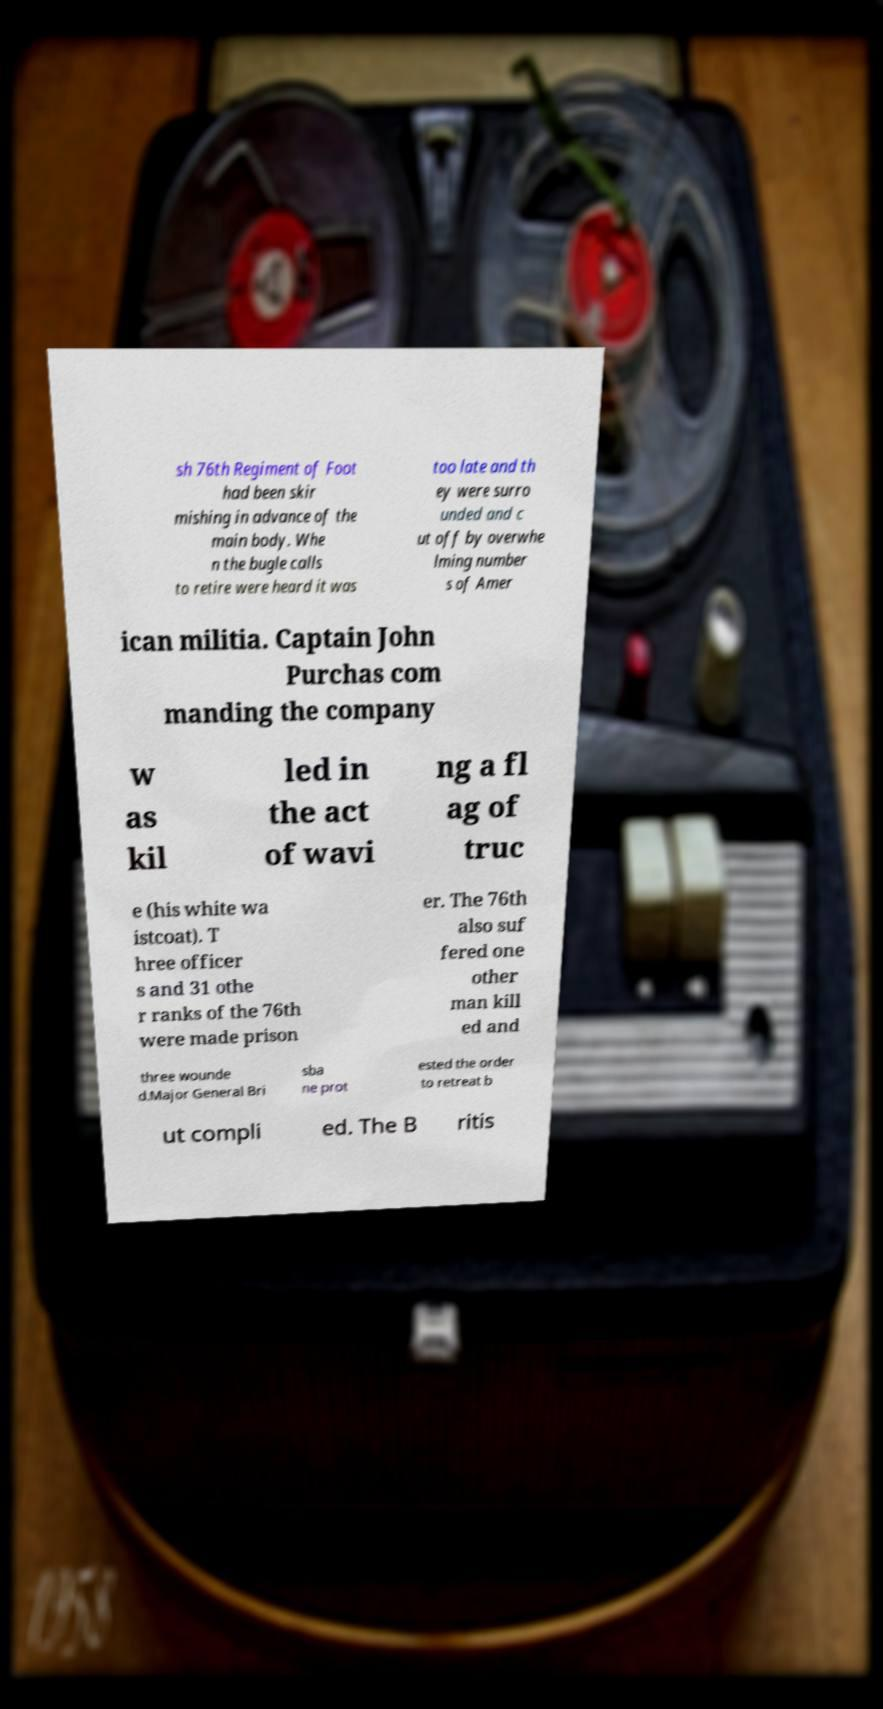Please read and relay the text visible in this image. What does it say? sh 76th Regiment of Foot had been skir mishing in advance of the main body. Whe n the bugle calls to retire were heard it was too late and th ey were surro unded and c ut off by overwhe lming number s of Amer ican militia. Captain John Purchas com manding the company w as kil led in the act of wavi ng a fl ag of truc e (his white wa istcoat). T hree officer s and 31 othe r ranks of the 76th were made prison er. The 76th also suf fered one other man kill ed and three wounde d.Major General Bri sba ne prot ested the order to retreat b ut compli ed. The B ritis 